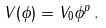<formula> <loc_0><loc_0><loc_500><loc_500>V ( \phi ) = V _ { 0 } \phi ^ { p } \, .</formula> 